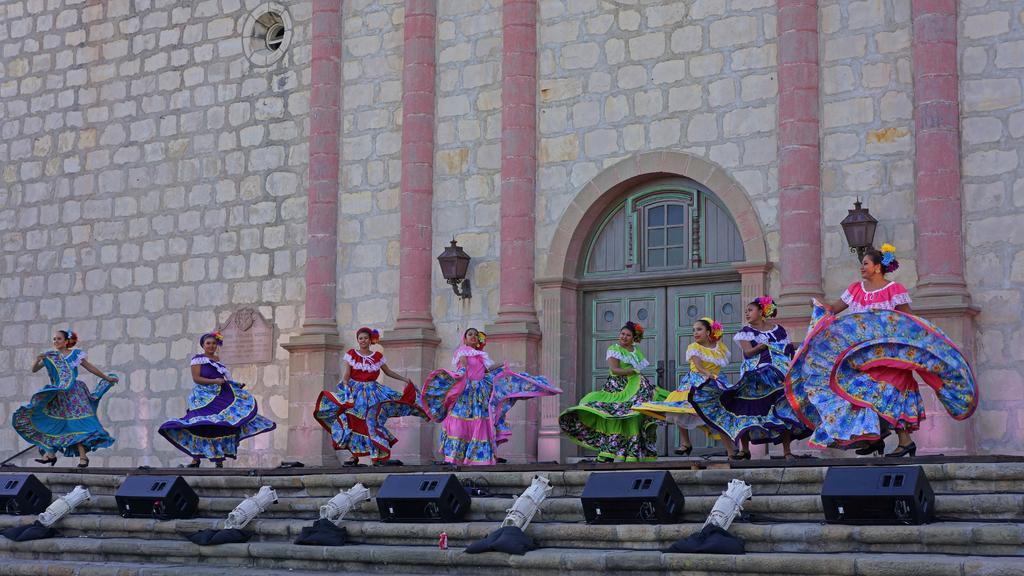Describe this image in one or two sentences. This picture seems to be clicked outside. In the foreground we can see the stairway, speakers and some other objects. In the center we can see the group of persons wearing frocks and seems to be dancing. In the background we can see the building and we can see the window and a door of the building and we can see the wall mounted lamps and we can see some other objects. 